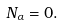Convert formula to latex. <formula><loc_0><loc_0><loc_500><loc_500>N _ { \alpha } = 0 .</formula> 